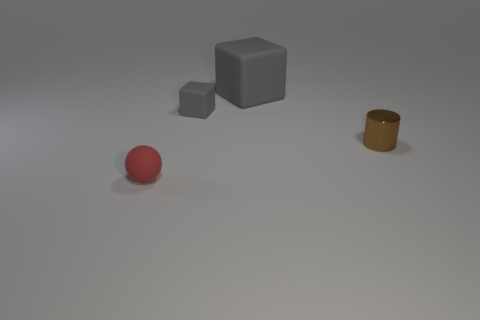Add 3 gray things. How many objects exist? 7 Subtract all cylinders. How many objects are left? 3 Add 1 small rubber blocks. How many small rubber blocks exist? 2 Subtract 0 purple cylinders. How many objects are left? 4 Subtract all matte balls. Subtract all small blue metallic cylinders. How many objects are left? 3 Add 1 tiny spheres. How many tiny spheres are left? 2 